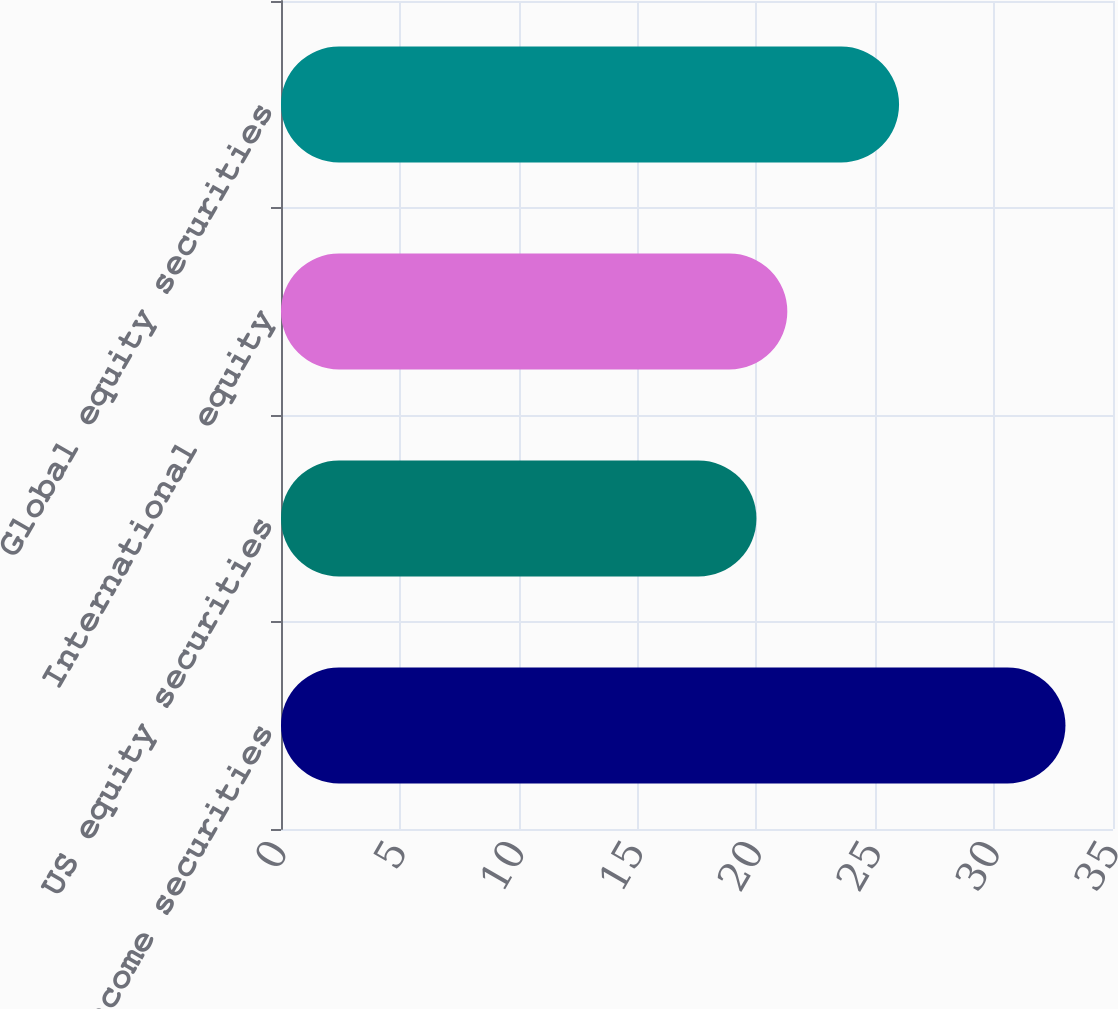Convert chart. <chart><loc_0><loc_0><loc_500><loc_500><bar_chart><fcel>US fixed income securities<fcel>US equity securities<fcel>International equity<fcel>Global equity securities<nl><fcel>33<fcel>20<fcel>21.3<fcel>26<nl></chart> 